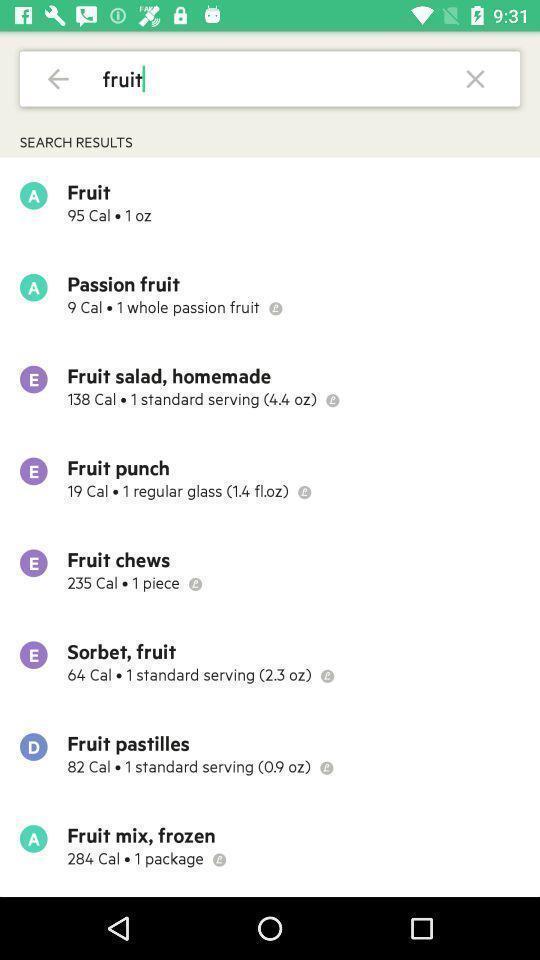Explain what's happening in this screen capture. Page showing search bar to find different healthy recipes. 